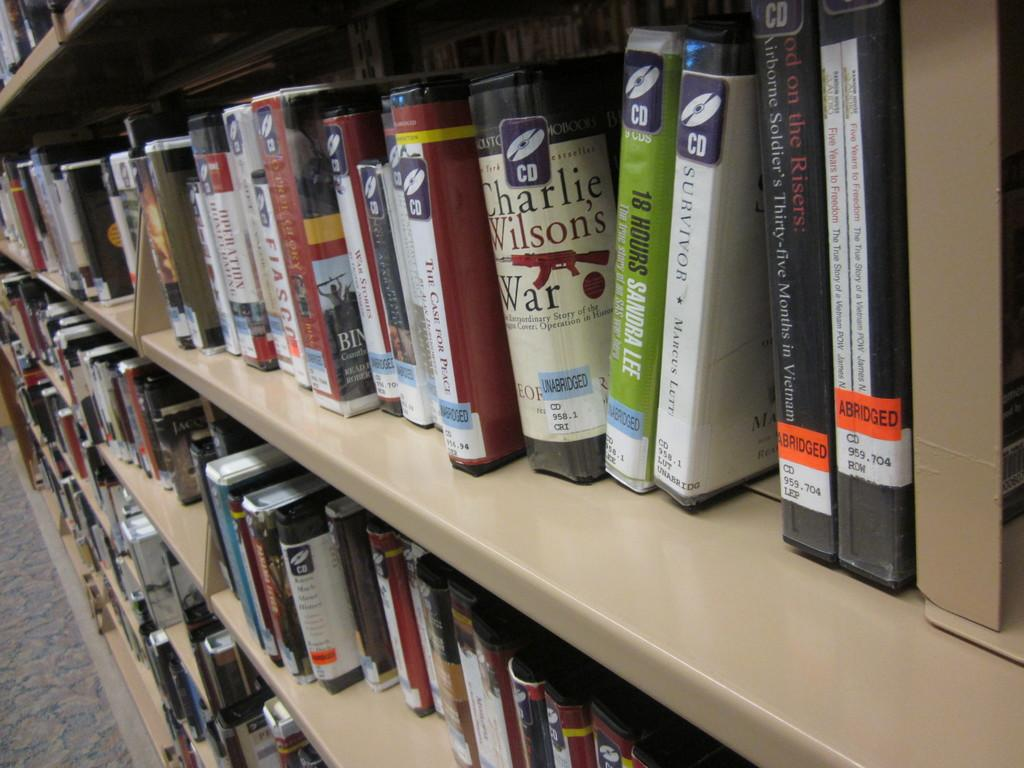<image>
Present a compact description of the photo's key features. Out of all of the books on the shelf, Charlie Wilson's War stands out. 